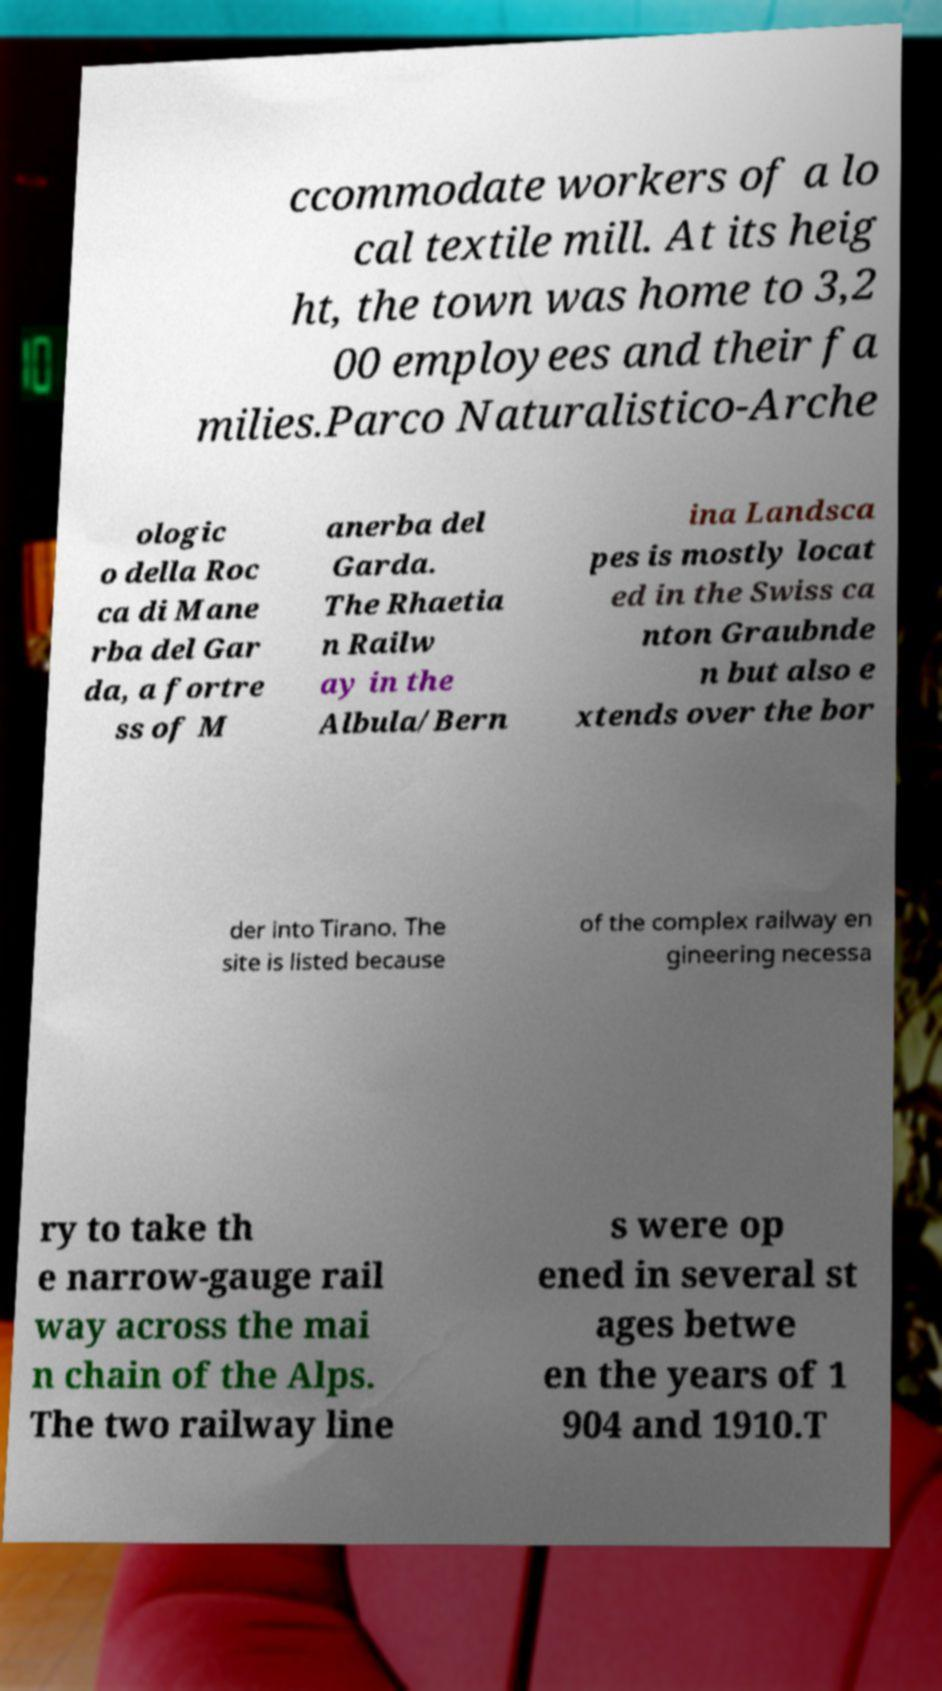Can you accurately transcribe the text from the provided image for me? ccommodate workers of a lo cal textile mill. At its heig ht, the town was home to 3,2 00 employees and their fa milies.Parco Naturalistico-Arche ologic o della Roc ca di Mane rba del Gar da, a fortre ss of M anerba del Garda. The Rhaetia n Railw ay in the Albula/Bern ina Landsca pes is mostly locat ed in the Swiss ca nton Graubnde n but also e xtends over the bor der into Tirano. The site is listed because of the complex railway en gineering necessa ry to take th e narrow-gauge rail way across the mai n chain of the Alps. The two railway line s were op ened in several st ages betwe en the years of 1 904 and 1910.T 